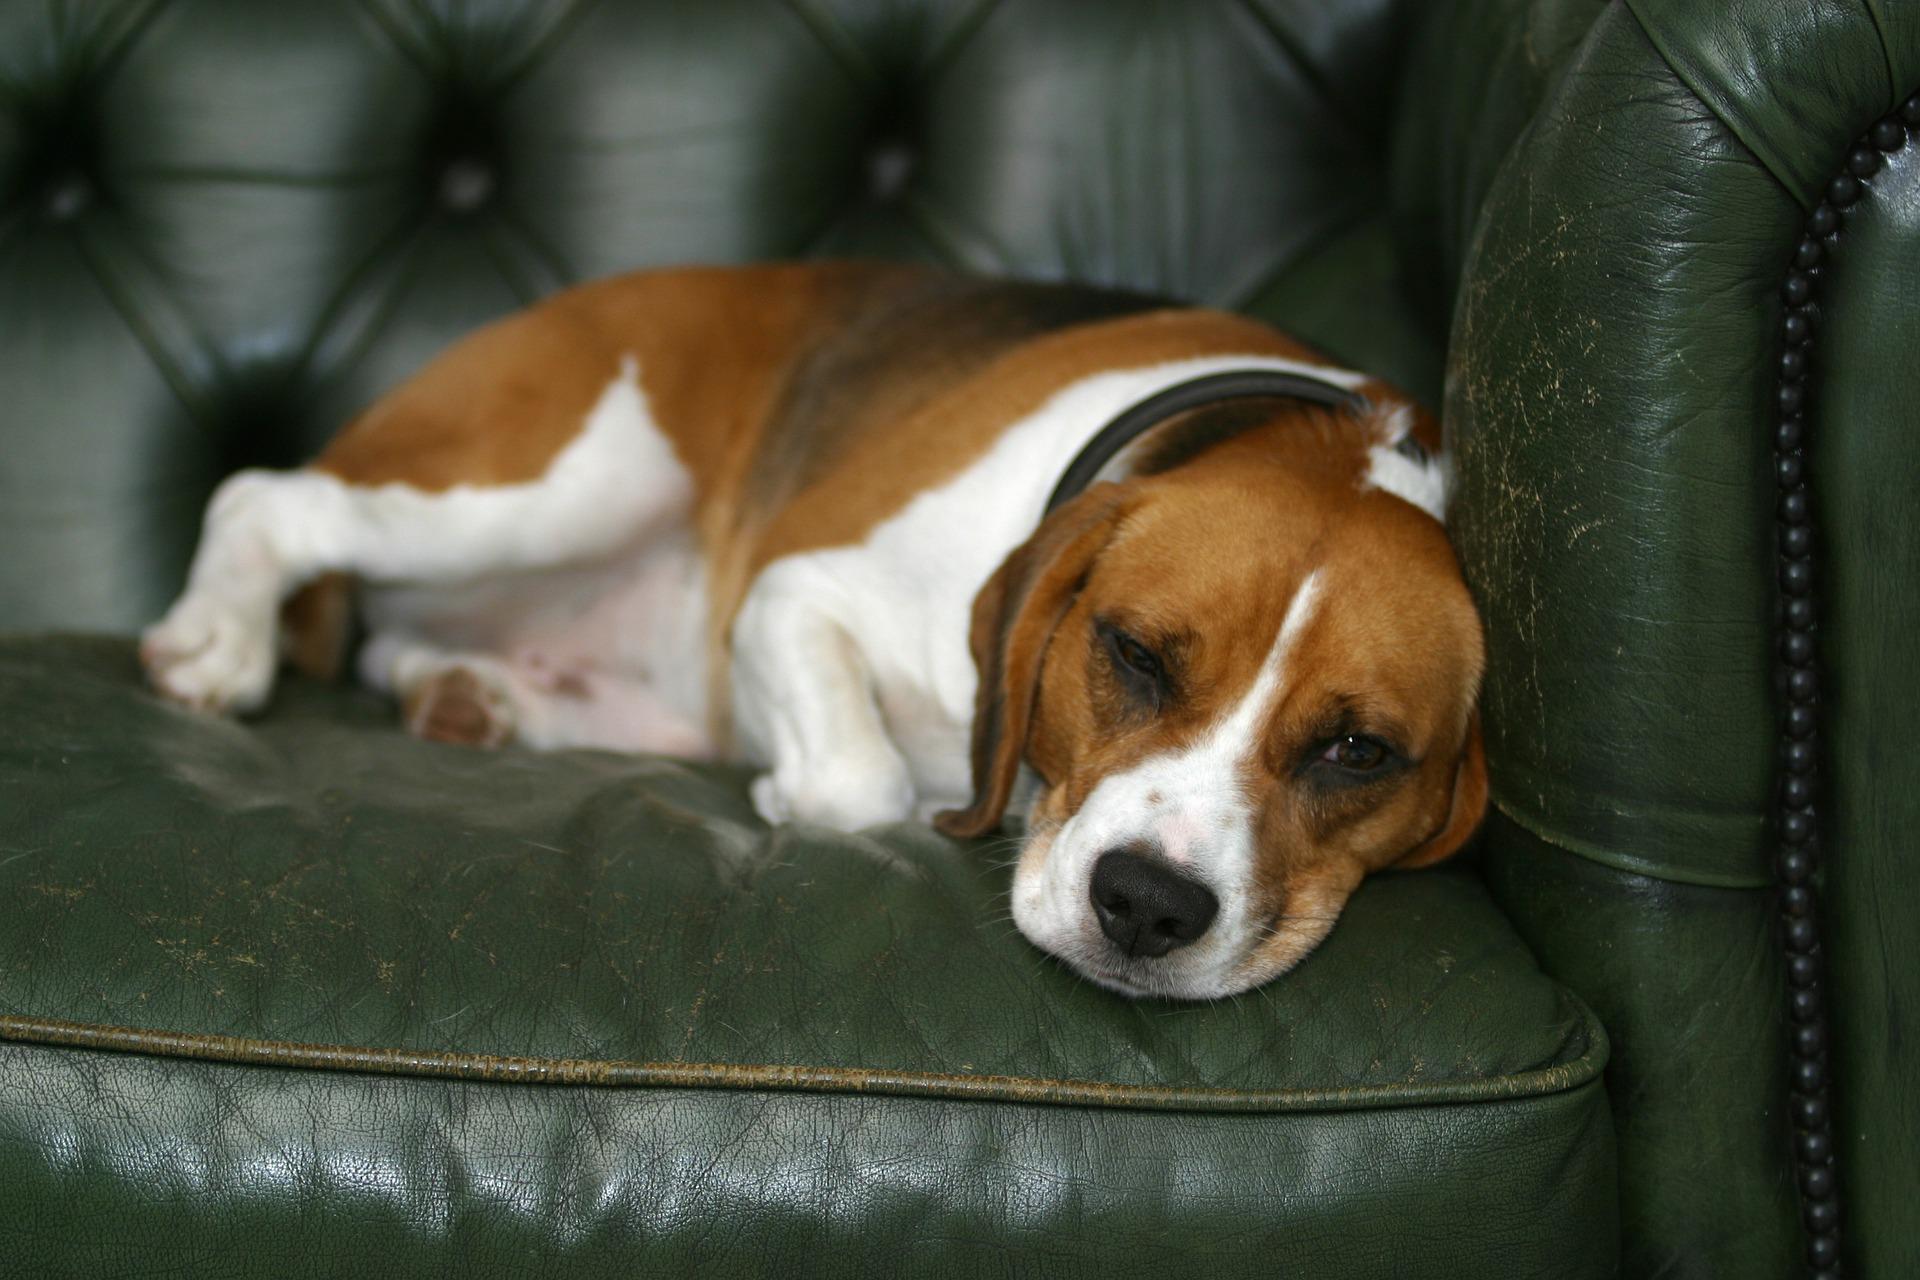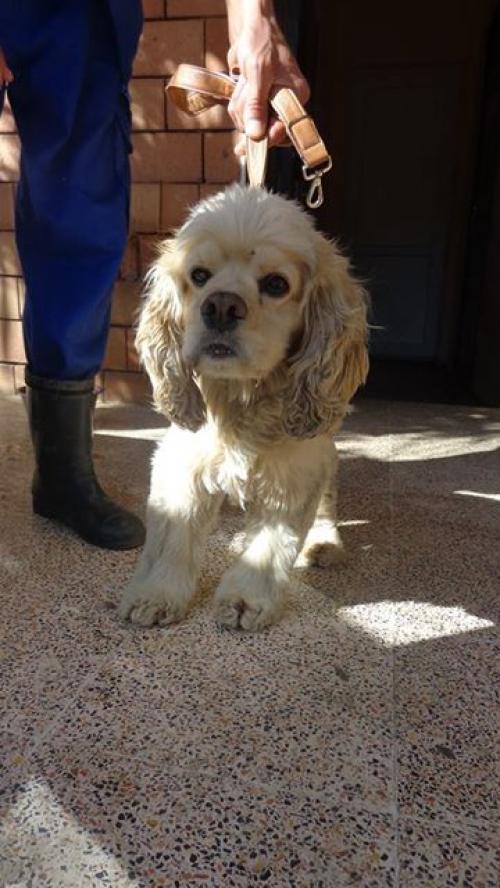The first image is the image on the left, the second image is the image on the right. Evaluate the accuracy of this statement regarding the images: "One image includes at least one spaniel in a sleeping pose with shut eyes, and the other includes at least one 'ginger' spaniel with open eyes.". Is it true? Answer yes or no. No. 